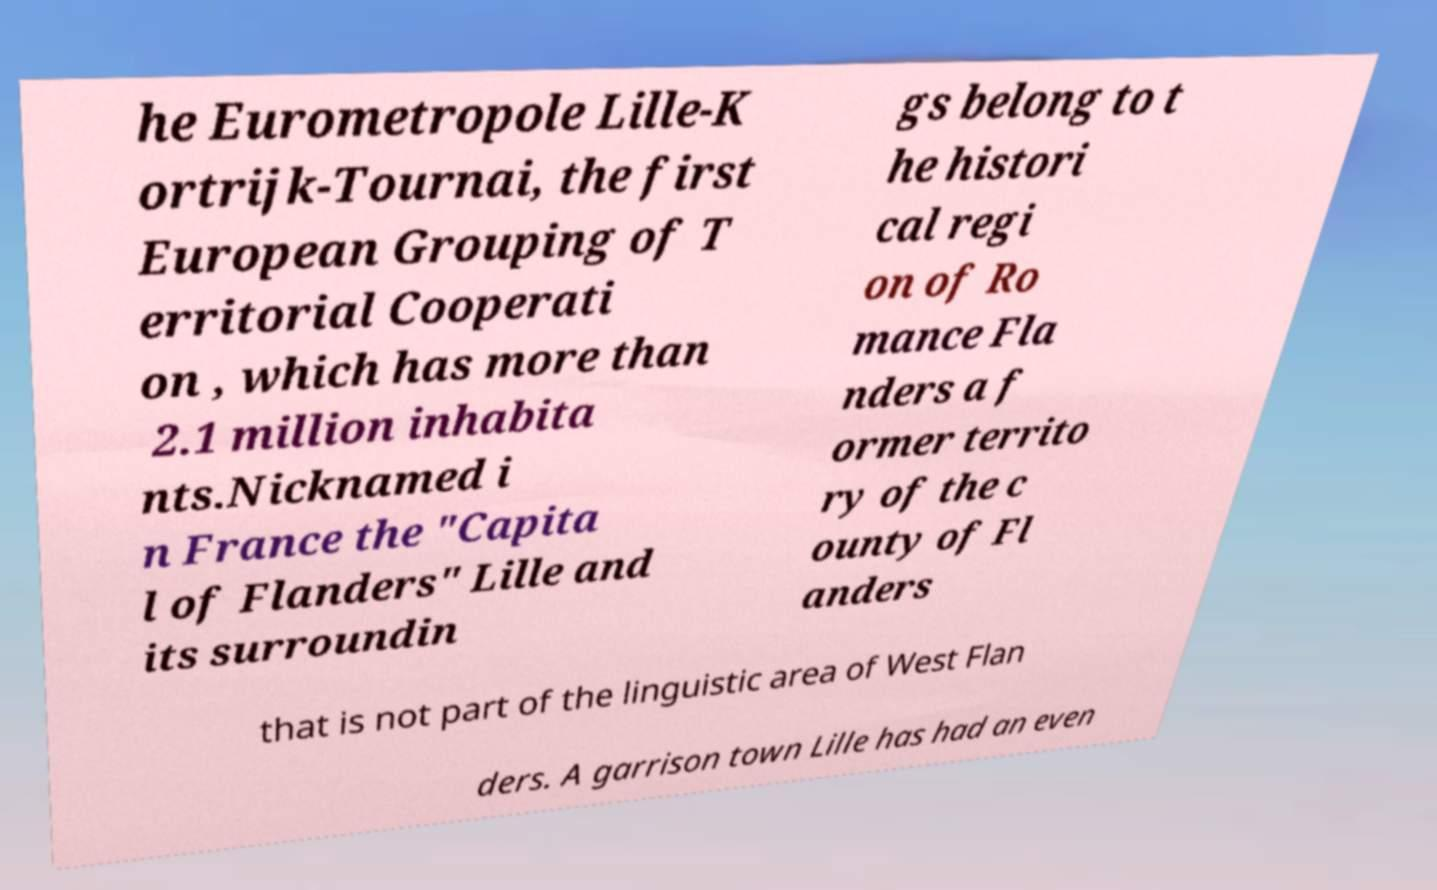Can you accurately transcribe the text from the provided image for me? he Eurometropole Lille-K ortrijk-Tournai, the first European Grouping of T erritorial Cooperati on , which has more than 2.1 million inhabita nts.Nicknamed i n France the "Capita l of Flanders" Lille and its surroundin gs belong to t he histori cal regi on of Ro mance Fla nders a f ormer territo ry of the c ounty of Fl anders that is not part of the linguistic area of West Flan ders. A garrison town Lille has had an even 